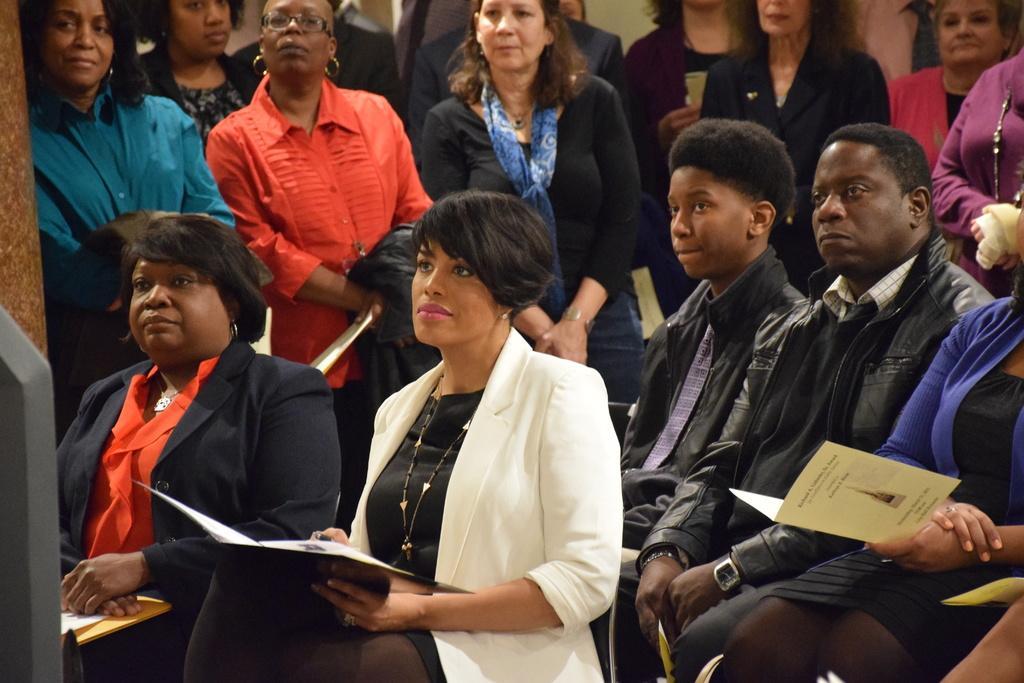Please provide a concise description of this image. In this image there are group of people sitting on the chairs , were two of them are holding cards , and in the background there are group of people standing. 